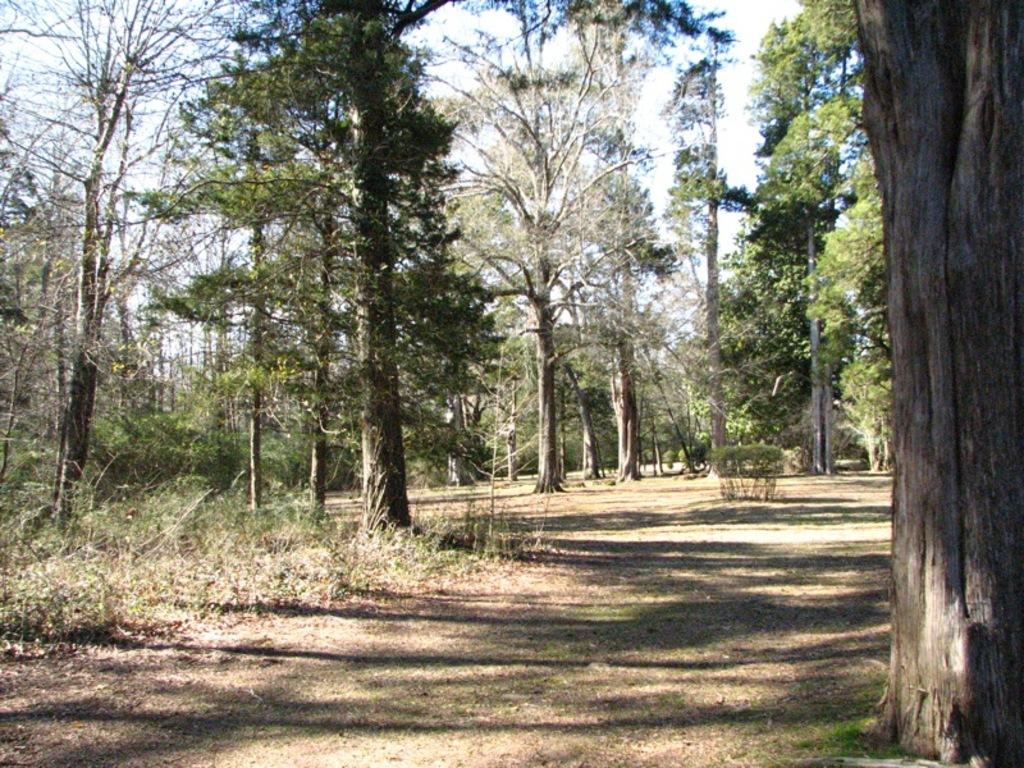What is at the bottom of the image? There is ground at the bottom of the image. What can be seen in the image that is related to animals? There is a bark in the image. Where are trees located in the image? Trees are on the right corner, left side, and in the background of the image. What is visible at the top of the image? There is sky visible at the top of the image. What type of property is being copied in the image? There is no property or copying activity present in the image. Can you tell me how many baths are visible in the image? There are no baths visible in the image. 